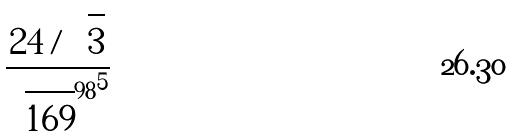Convert formula to latex. <formula><loc_0><loc_0><loc_500><loc_500>\frac { 2 4 / \sqrt { 3 } } { { \sqrt { 1 6 9 } ^ { 9 8 } } ^ { 5 } }</formula> 